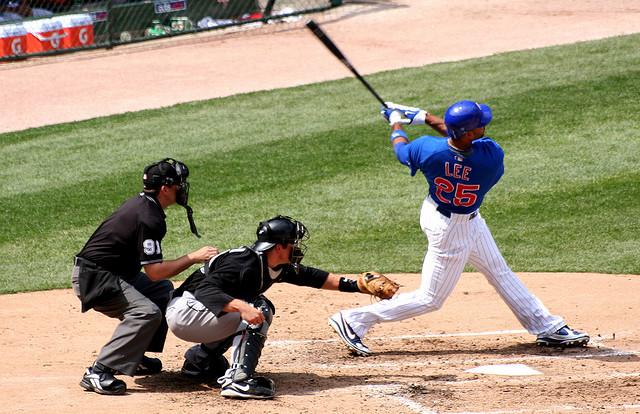What number is on the back of the man's shirt?
Keep it brief. 25. What is the number on the umpire's shirt?
Concise answer only. 91. What team does the batter play for?
Concise answer only. Cubs. What is the batter's last name?
Answer briefly. Lee. 